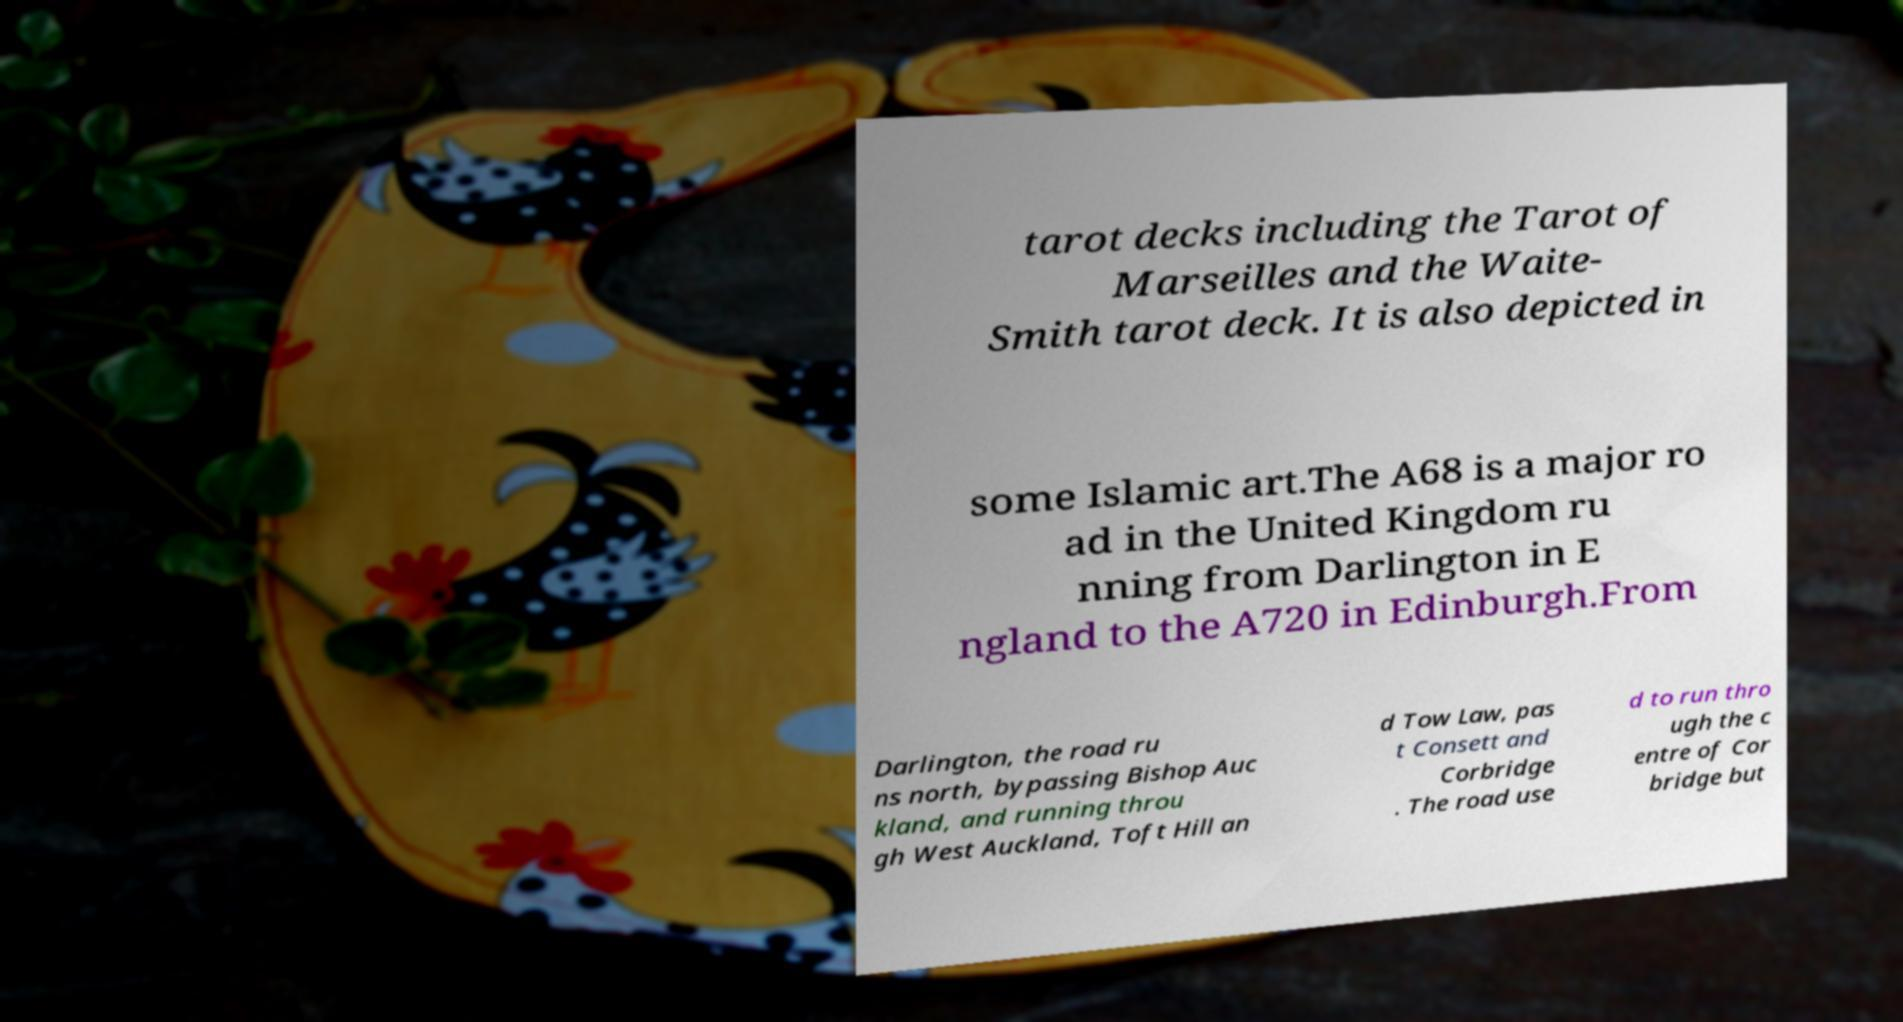For documentation purposes, I need the text within this image transcribed. Could you provide that? tarot decks including the Tarot of Marseilles and the Waite- Smith tarot deck. It is also depicted in some Islamic art.The A68 is a major ro ad in the United Kingdom ru nning from Darlington in E ngland to the A720 in Edinburgh.From Darlington, the road ru ns north, bypassing Bishop Auc kland, and running throu gh West Auckland, Toft Hill an d Tow Law, pas t Consett and Corbridge . The road use d to run thro ugh the c entre of Cor bridge but 